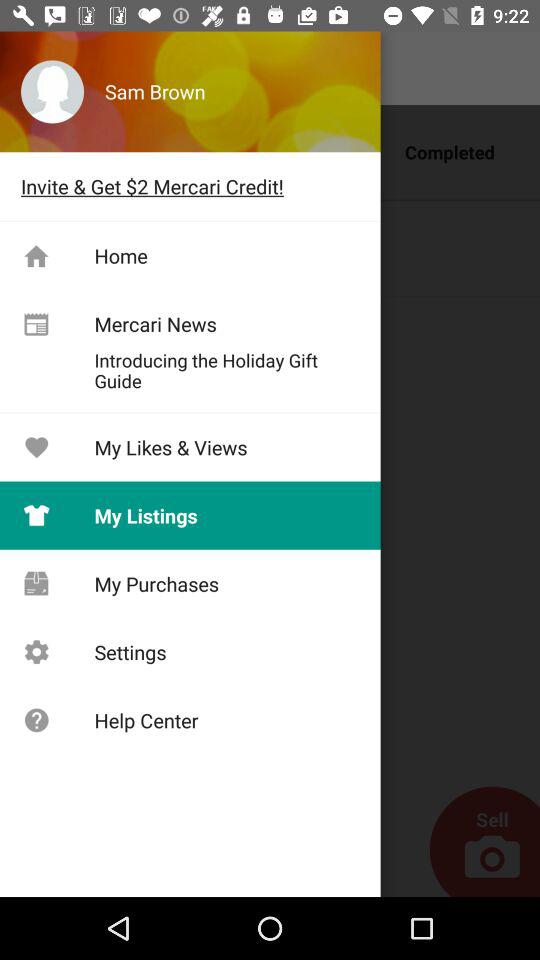How can the user get Mercari Credit? The user can get Mercari Credit by sending an invite. 